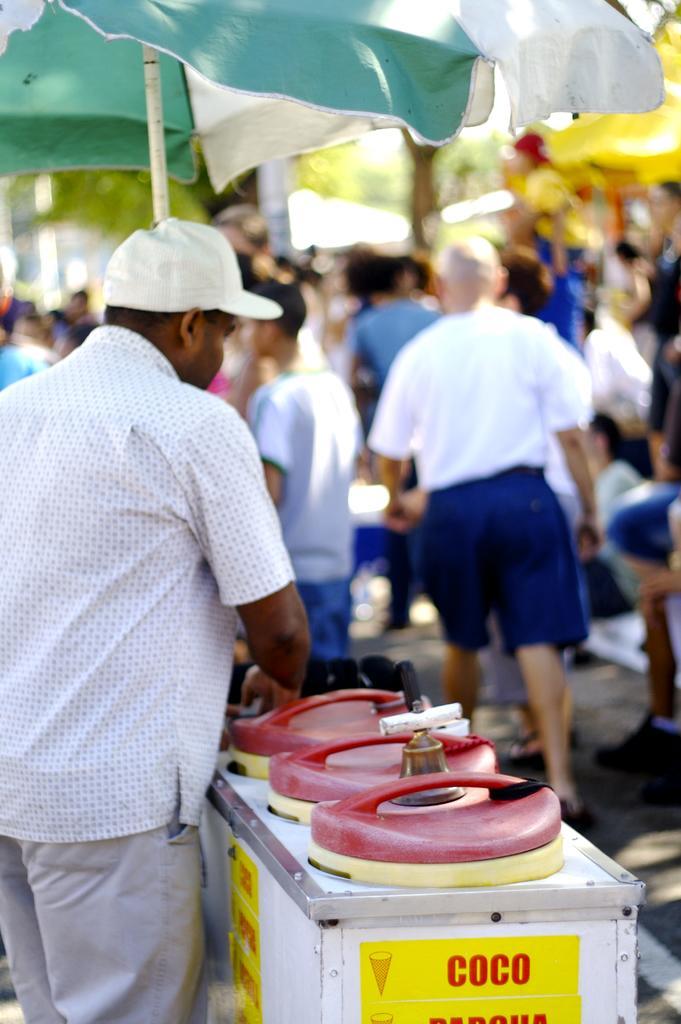How would you summarize this image in a sentence or two? In this image we can see a person wearing a white shirt and a cap is standing in front of a table on which a bell and group of containers are placed on it. In the background we can see group of people standing, umbrella and some trees. 